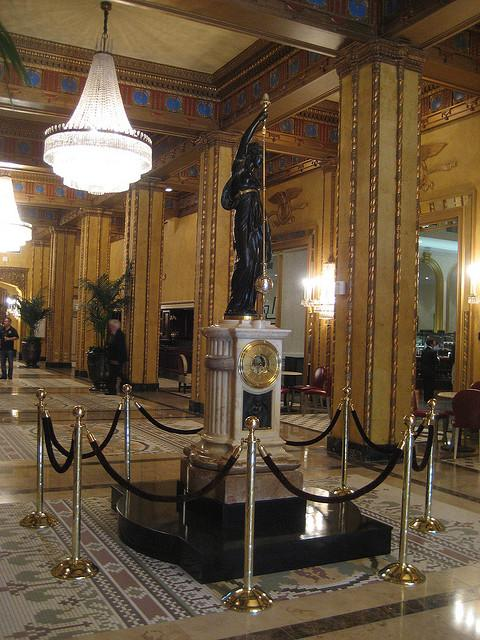Why is there a rope around this statue?

Choices:
A) prevent damage
B) law
C) style
D) religious reasons prevent damage 